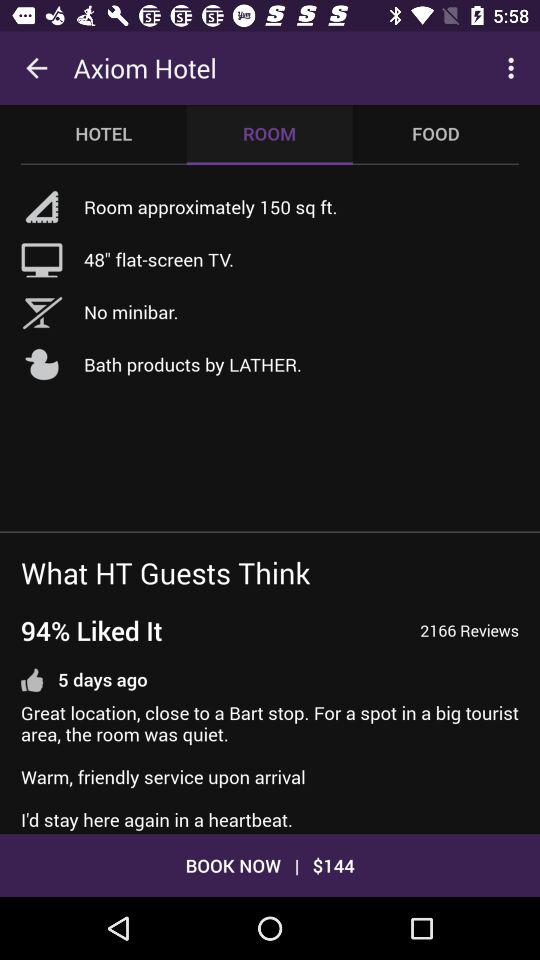What percentage of the guests liked the hotel? There were 94% of the guests that liked the hotel. 